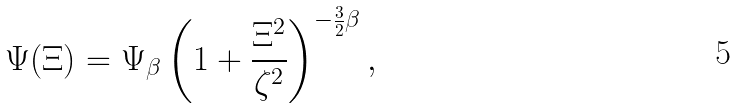Convert formula to latex. <formula><loc_0><loc_0><loc_500><loc_500>\Psi ( \Xi ) = \Psi _ { \beta } \left ( 1 + \frac { \Xi ^ { 2 } } { \zeta ^ { 2 } } \right ) ^ { - \frac { 3 } { 2 } \beta } ,</formula> 